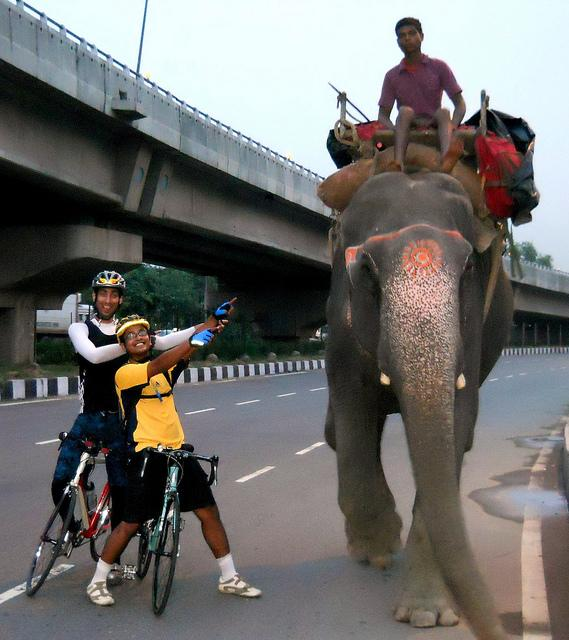What are the helmets shells made from? Please explain your reasoning. plastic. Helmets are most commonly made with a plastic shell and the helmets visible look like standard helmets that would be made from the most common materials. 